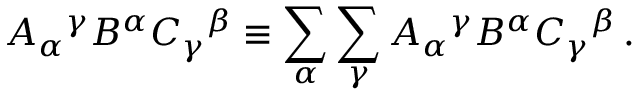Convert formula to latex. <formula><loc_0><loc_0><loc_500><loc_500>A _ { \alpha ^ { \gamma } B ^ { \alpha } C _ { \gamma ^ { \beta } \equiv \sum _ { \alpha } \sum _ { \gamma } A _ { \alpha ^ { \gamma } B ^ { \alpha } C _ { \gamma ^ { \beta } \, .</formula> 